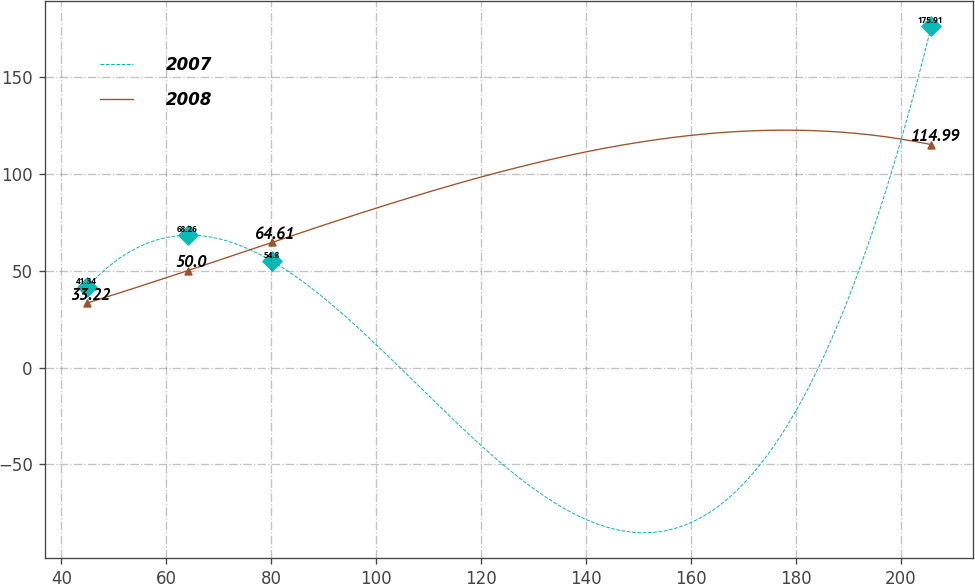Convert chart. <chart><loc_0><loc_0><loc_500><loc_500><line_chart><ecel><fcel>2007<fcel>2008<nl><fcel>44.85<fcel>41.34<fcel>33.22<nl><fcel>64.11<fcel>68.26<fcel>50<nl><fcel>80.2<fcel>54.8<fcel>64.61<nl><fcel>205.79<fcel>175.91<fcel>114.99<nl></chart> 